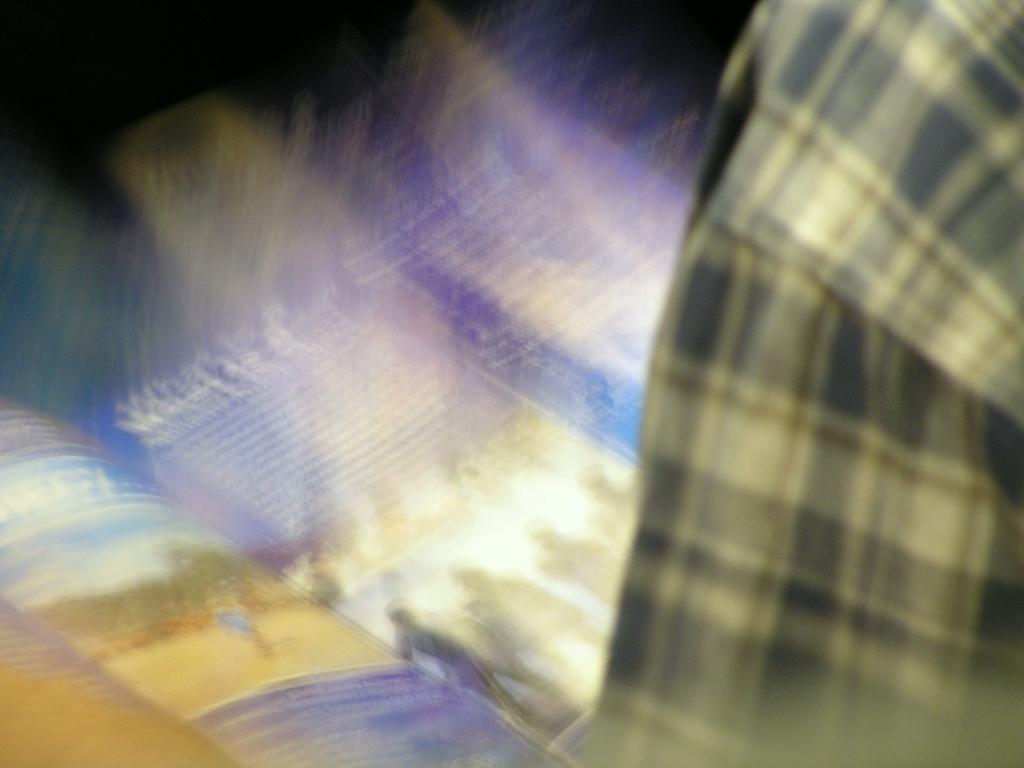What object can be seen in the image? There is a book in the image. Can you describe any part of a person in the image? There is a person's shoulder on the right side of the image. What does the stranger say to the person's dad in the image? There is no stranger or person's dad present in the image, so it is not possible to answer that question. 